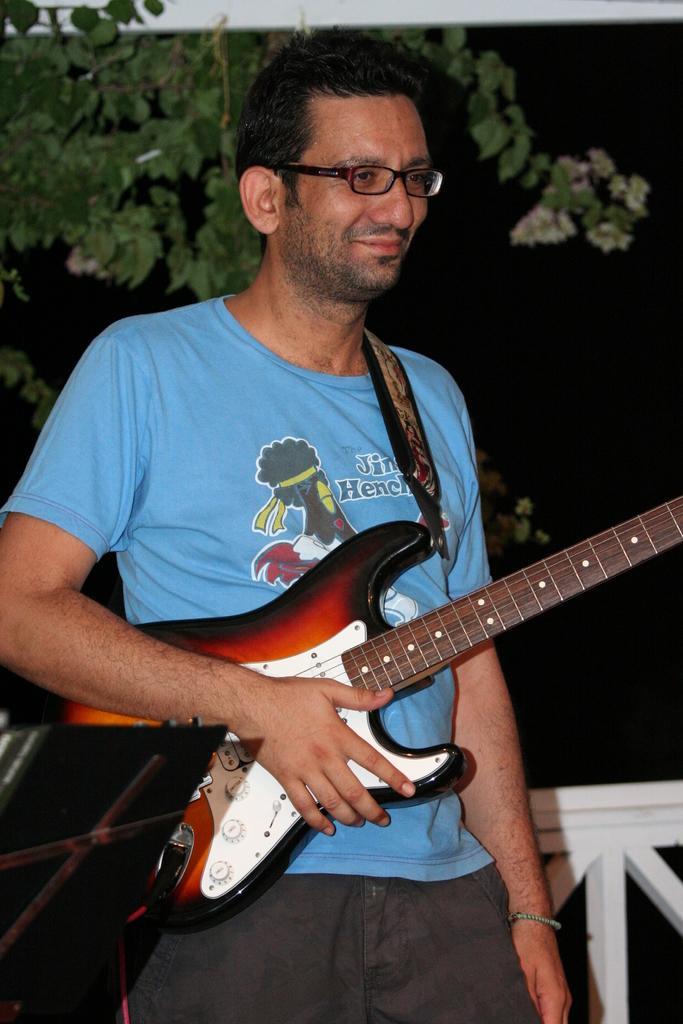Can you describe this image briefly? The person wearing blue shirt is holding a guitar in his hands and there is a tree in the background. 